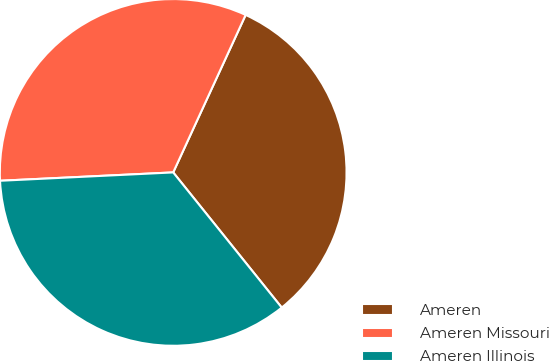<chart> <loc_0><loc_0><loc_500><loc_500><pie_chart><fcel>Ameren<fcel>Ameren Missouri<fcel>Ameren Illinois<nl><fcel>32.37%<fcel>32.63%<fcel>35.0%<nl></chart> 